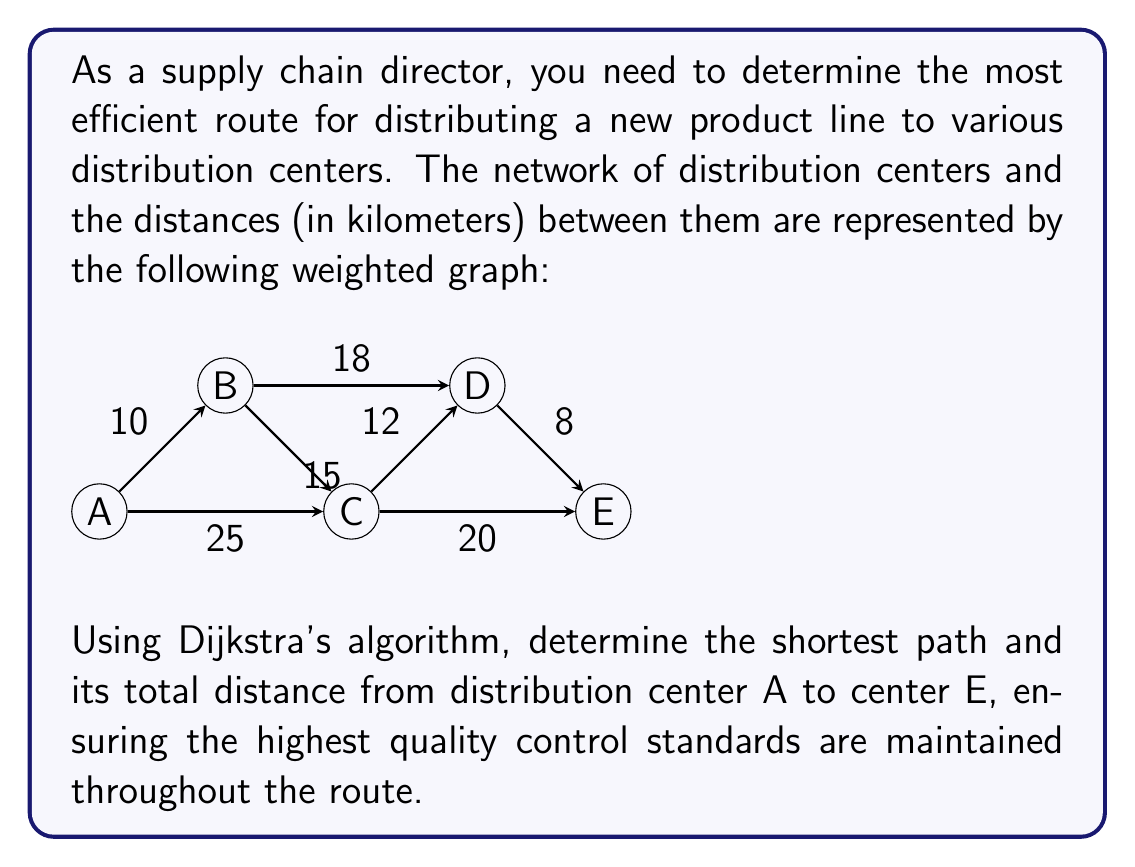Can you answer this question? To solve this problem using Dijkstra's algorithm, we'll follow these steps:

1) Initialize:
   - Set distance to A as 0 and all other nodes as infinity.
   - Set all nodes as unvisited.
   - Set A as the current node.

2) For the current node, consider all unvisited neighbors and calculate their tentative distances.
3) Mark the current node as visited. A visited node will not be checked again.
4) If the destination node (E) has been marked visited, we're done.
5) Otherwise, select the unvisited node with the smallest tentative distance and set it as the new current node. Go back to step 2.

Let's apply the algorithm:

Starting at A:
- Update B: min(∞, 0 + 10) = 10
- Update C: min(∞, 0 + 25) = 25
- Mark A as visited

Current distances: A(0), B(10), C(25), D(∞), E(∞)

At B:
- Update C: min(25, 10 + 15) = 25
- Update D: min(∞, 10 + 18) = 28
- Mark B as visited

Current distances: A(0), B(10), C(25), D(28), E(∞)

At C:
- Update D: min(28, 25 + 12) = 28
- Update E: min(∞, 25 + 20) = 45
- Mark C as visited

Current distances: A(0), B(10), C(25), D(28), E(45)

At D:
- Update E: min(45, 28 + 8) = 36
- Mark D as visited

Current distances: A(0), B(10), C(25), D(28), E(36)

The algorithm terminates as we've reached E.

The shortest path is A → B → D → E with a total distance of 36 km.

This route ensures the highest quality control standards by minimizing the total distance traveled, which reduces the risk of product damage or deterioration during transit.
Answer: The shortest path from A to E is A → B → D → E, with a total distance of 36 km. 